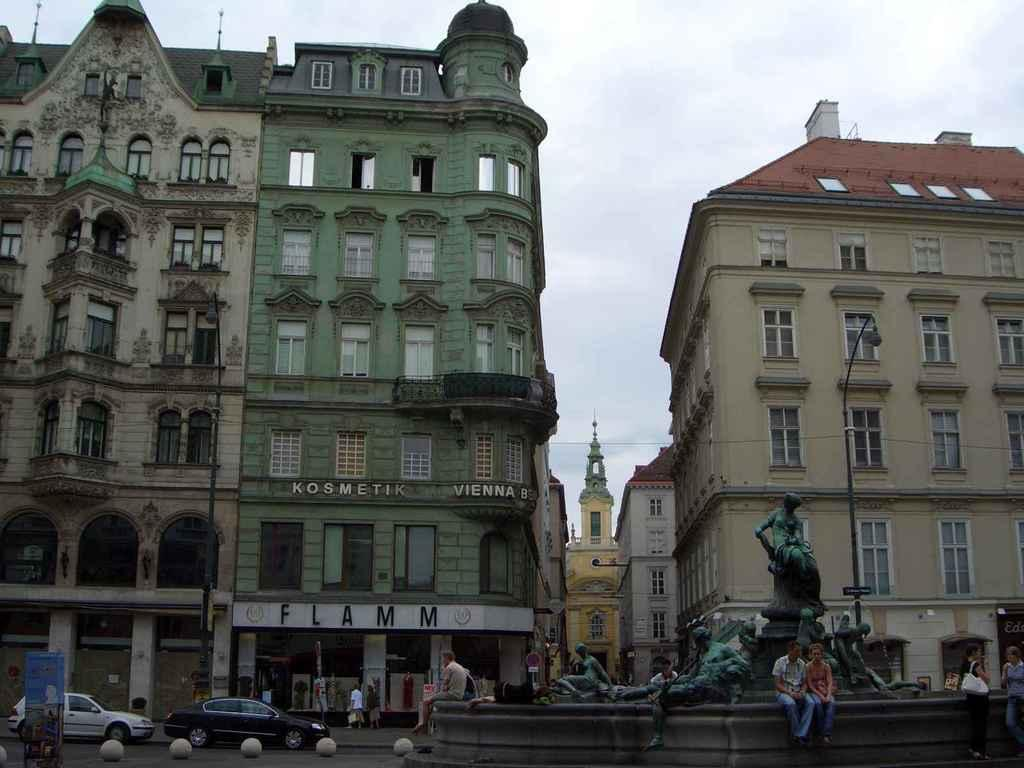<image>
Summarize the visual content of the image. People in Vienna surround a statue with a building in the background that says FLAMM. 